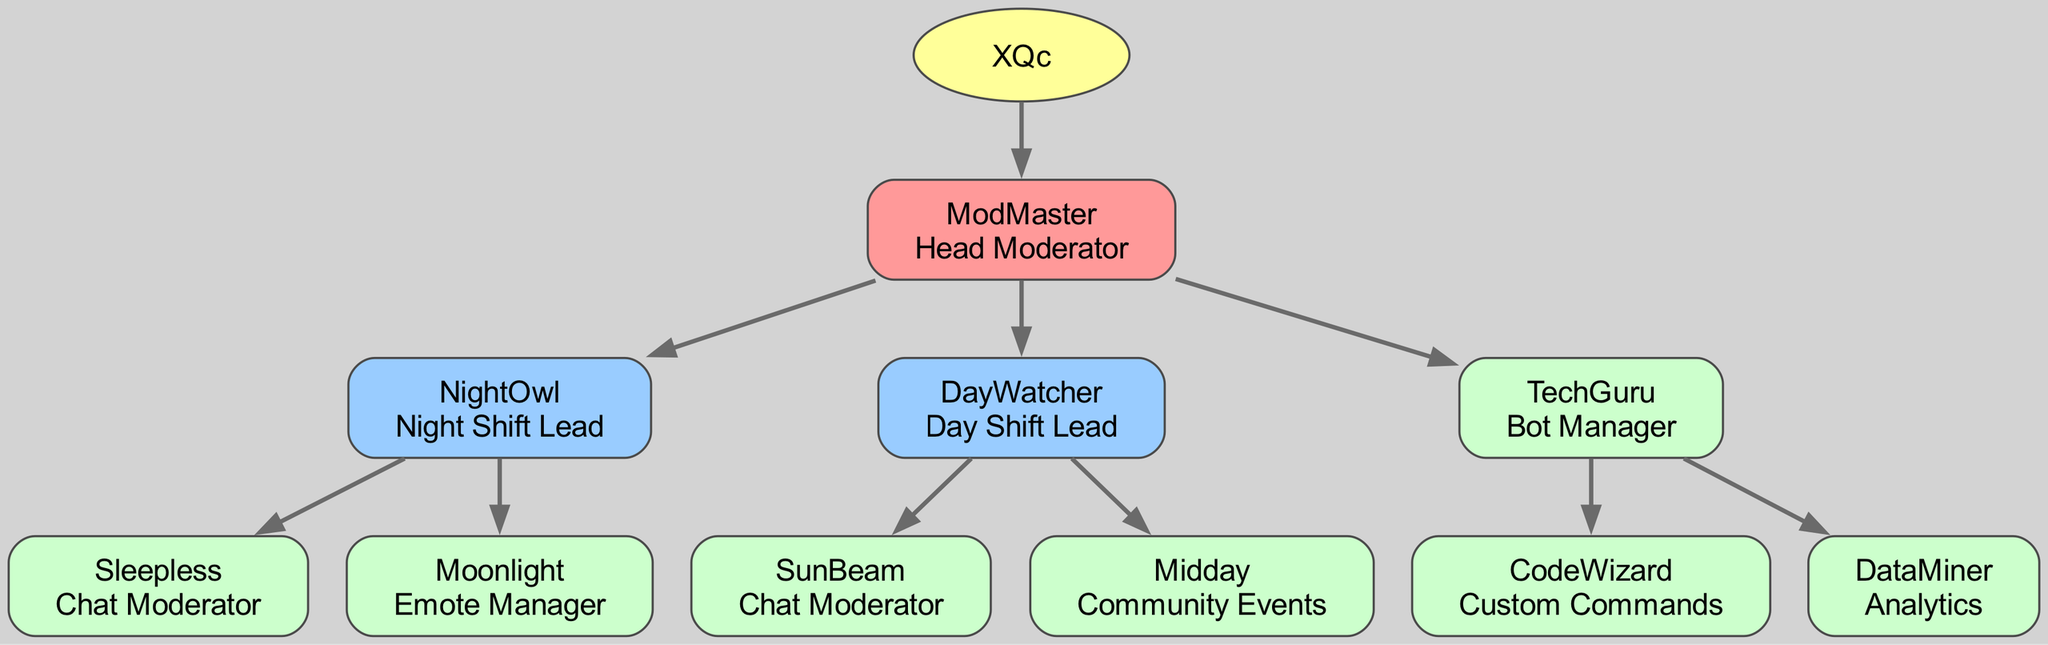What is the role of the root node? The root node is "XQc," and according to the diagram, there is no specific role assigned to the root; it primarily indicates the top-level entity of the family tree.
Answer: XQc How many children does ModMaster have? ModMaster, as indicated in the diagram, has three children: NightOwl, DayWatcher, and TechGuru. Therefore, the total count is 3.
Answer: 3 Who is responsible for managing custom commands? Looking at the diagram, "CodeWizard" is listed under TechGuru as the role responsible for custom commands.
Answer: CodeWizard What role does Sleepless have? Sleepless is listed directly as a child of NightOwl in the diagram, and its specific role is defined as "Chat Moderator."
Answer: Chat Moderator Which moderator is responsible for Community Events? The diagram shows that Midday is a child of DayWatcher and is specifically designated as responsible for Community Events.
Answer: Midday Who oversees the Night Shift Lead? By tracing the relationship in the diagram, NightOwl is identified under ModMaster, indicating that ModMaster oversees NightOwl as the Night Shift Lead.
Answer: ModMaster How many roles are there for Chat Moderators in total? The diagram indicates there are two roles identified as Chat Moderators: Sleepless under NightOwl and SunBeam under DayWatcher. Summing these gives a total of 2.
Answer: 2 Which role is filled by Moonlight? The diagram shows that Moonlight is a child of NightOwl and defines the role of "Emote Manager."
Answer: Emote Manager Who is the direct child of TechGuru? The diagram reveals that TechGuru has two children: CodeWizard and DataMiner. Therefore, any direct child can be either; thus, the answer can be any one of them. The first mentioned is CodeWizard.
Answer: CodeWizard 